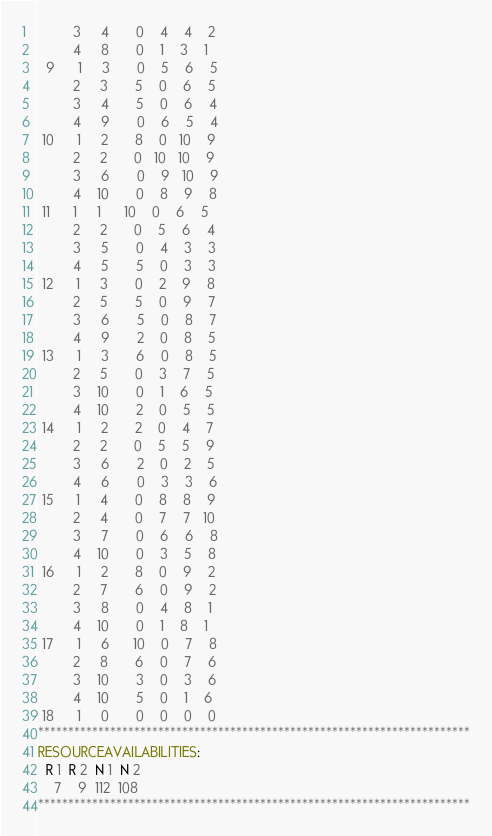Convert code to text. <code><loc_0><loc_0><loc_500><loc_500><_ObjectiveC_>         3     4       0    4    4    2
         4     8       0    1    3    1
  9      1     3       0    5    6    5
         2     3       5    0    6    5
         3     4       5    0    6    4
         4     9       0    6    5    4
 10      1     2       8    0   10    9
         2     2       0   10   10    9
         3     6       0    9   10    9
         4    10       0    8    9    8
 11      1     1      10    0    6    5
         2     2       0    5    6    4
         3     5       0    4    3    3
         4     5       5    0    3    3
 12      1     3       0    2    9    8
         2     5       5    0    9    7
         3     6       5    0    8    7
         4     9       2    0    8    5
 13      1     3       6    0    8    5
         2     5       0    3    7    5
         3    10       0    1    6    5
         4    10       2    0    5    5
 14      1     2       2    0    4    7
         2     2       0    5    5    9
         3     6       2    0    2    5
         4     6       0    3    3    6
 15      1     4       0    8    8    9
         2     4       0    7    7   10
         3     7       0    6    6    8
         4    10       0    3    5    8
 16      1     2       8    0    9    2
         2     7       6    0    9    2
         3     8       0    4    8    1
         4    10       0    1    8    1
 17      1     6      10    0    7    8
         2     8       6    0    7    6
         3    10       3    0    3    6
         4    10       5    0    1    6
 18      1     0       0    0    0    0
************************************************************************
RESOURCEAVAILABILITIES:
  R 1  R 2  N 1  N 2
    7    9  112  108
************************************************************************
</code> 